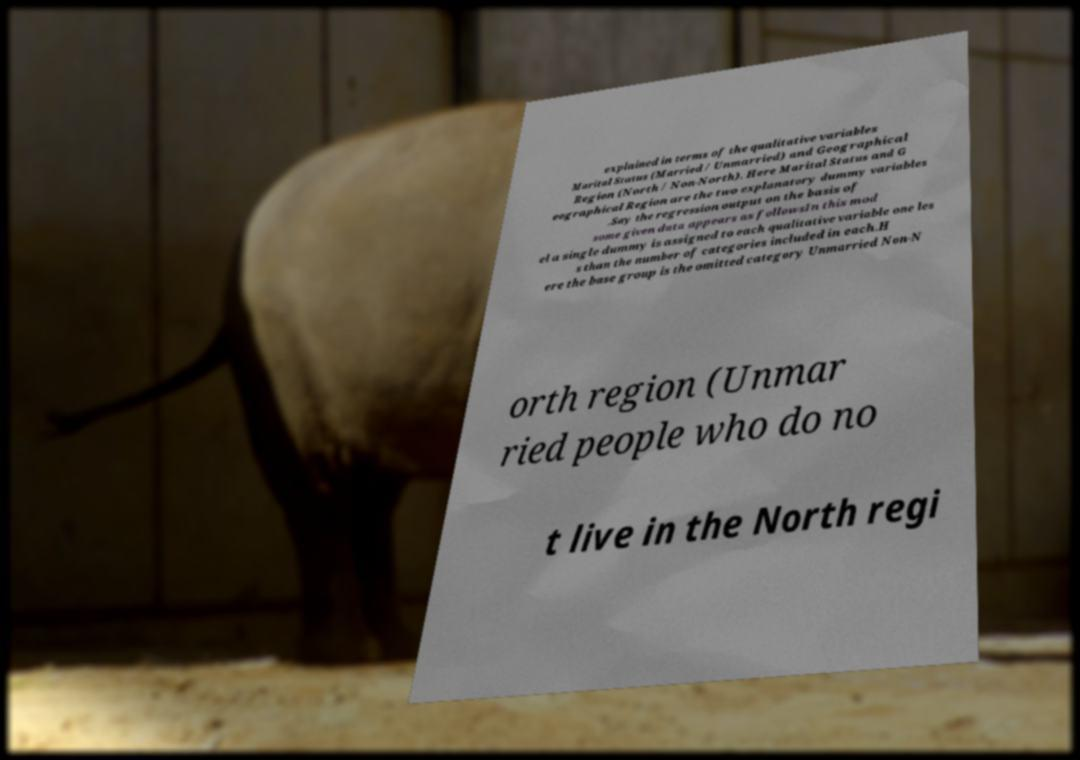Can you accurately transcribe the text from the provided image for me? explained in terms of the qualitative variables Marital Status (Married / Unmarried) and Geographical Region (North / Non-North). Here Marital Status and G eographical Region are the two explanatory dummy variables .Say the regression output on the basis of some given data appears as followsIn this mod el a single dummy is assigned to each qualitative variable one les s than the number of categories included in each.H ere the base group is the omitted category Unmarried Non-N orth region (Unmar ried people who do no t live in the North regi 